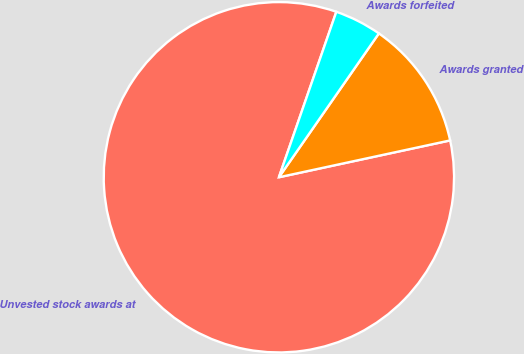Convert chart to OTSL. <chart><loc_0><loc_0><loc_500><loc_500><pie_chart><fcel>Unvested stock awards at<fcel>Awards granted<fcel>Awards forfeited<nl><fcel>83.7%<fcel>11.96%<fcel>4.35%<nl></chart> 